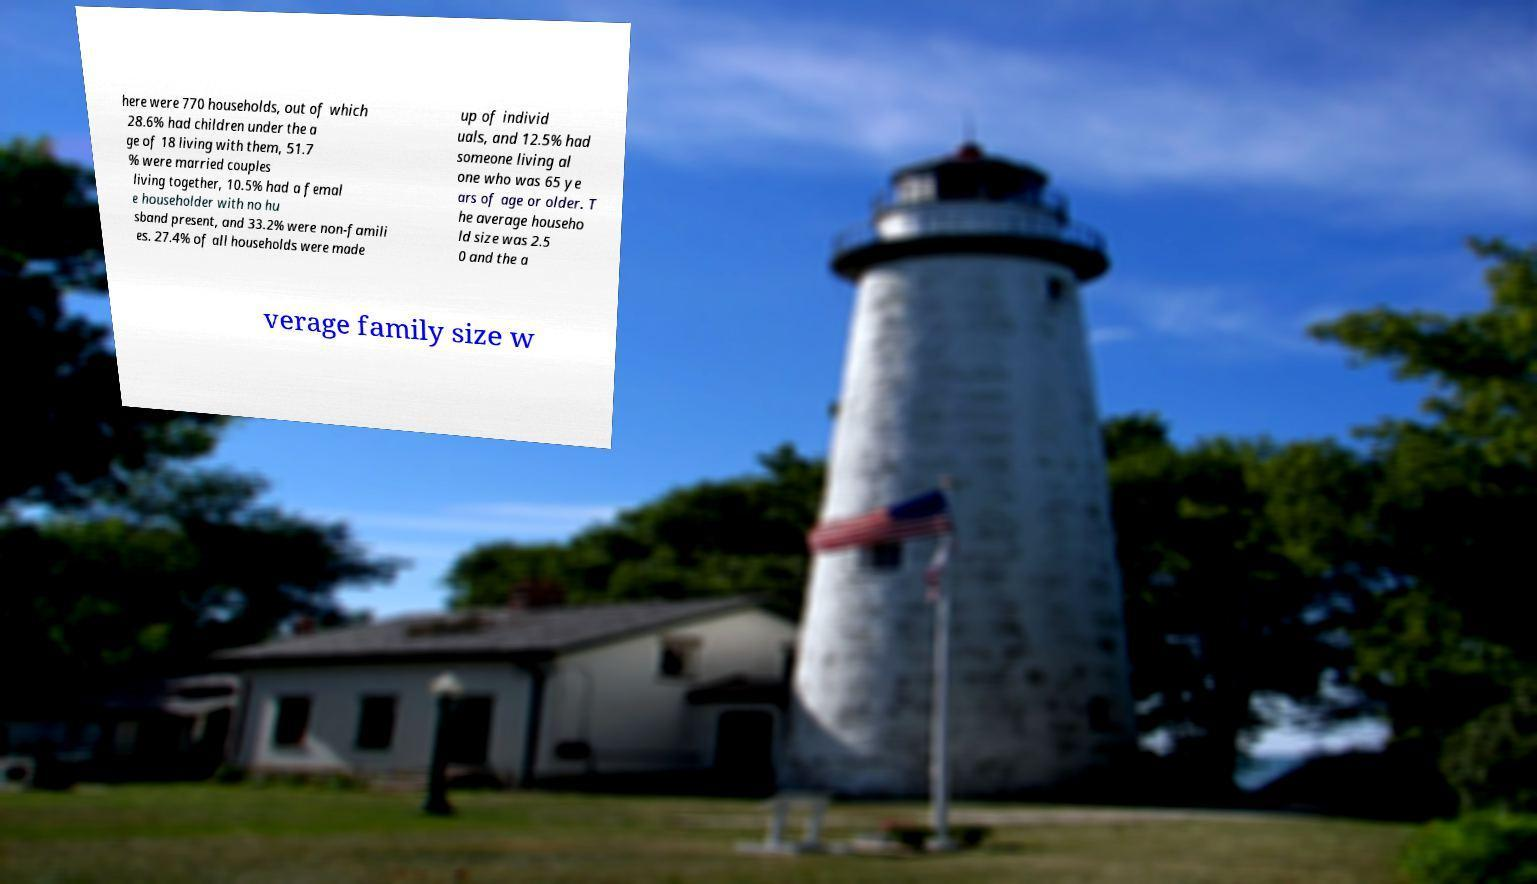I need the written content from this picture converted into text. Can you do that? here were 770 households, out of which 28.6% had children under the a ge of 18 living with them, 51.7 % were married couples living together, 10.5% had a femal e householder with no hu sband present, and 33.2% were non-famili es. 27.4% of all households were made up of individ uals, and 12.5% had someone living al one who was 65 ye ars of age or older. T he average househo ld size was 2.5 0 and the a verage family size w 